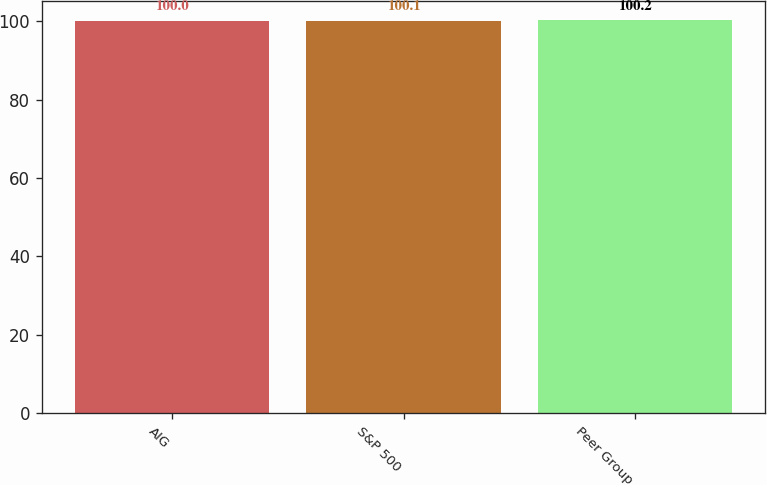Convert chart. <chart><loc_0><loc_0><loc_500><loc_500><bar_chart><fcel>AIG<fcel>S&P 500<fcel>Peer Group<nl><fcel>100<fcel>100.1<fcel>100.2<nl></chart> 